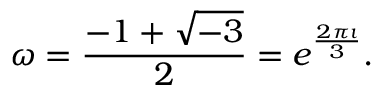Convert formula to latex. <formula><loc_0><loc_0><loc_500><loc_500>\omega = { \frac { - 1 + { \sqrt { - 3 } } } { 2 } } = e ^ { \frac { 2 \pi \imath } { 3 } } .</formula> 